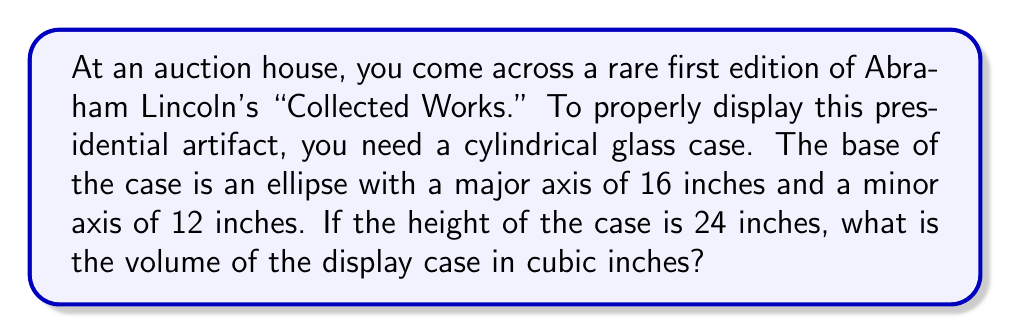Give your solution to this math problem. Let's approach this step-by-step:

1) The base of the cylinder is an ellipse. The volume of a cylinder with an elliptical base is given by the formula:

   $$V = \pi ab h$$

   where $a$ and $b$ are the semi-major and semi-minor axes of the ellipse, and $h$ is the height of the cylinder.

2) We're given the full lengths of the major and minor axes. To get the semi-axes, we need to divide these by 2:

   $a = 16/2 = 8$ inches
   $b = 12/2 = 6$ inches

3) The height $h$ is given as 24 inches.

4) Now we can substitute these values into our volume formula:

   $$V = \pi(8)(6)(24)$$

5) Simplify:

   $$V = 1152\pi$$

6) If we want to calculate this to a decimal approximation:

   $$V \approx 3619.12$$ cubic inches

However, leaving the answer in terms of $\pi$ is often preferred in mathematical contexts.
Answer: $1152\pi$ cubic inches 